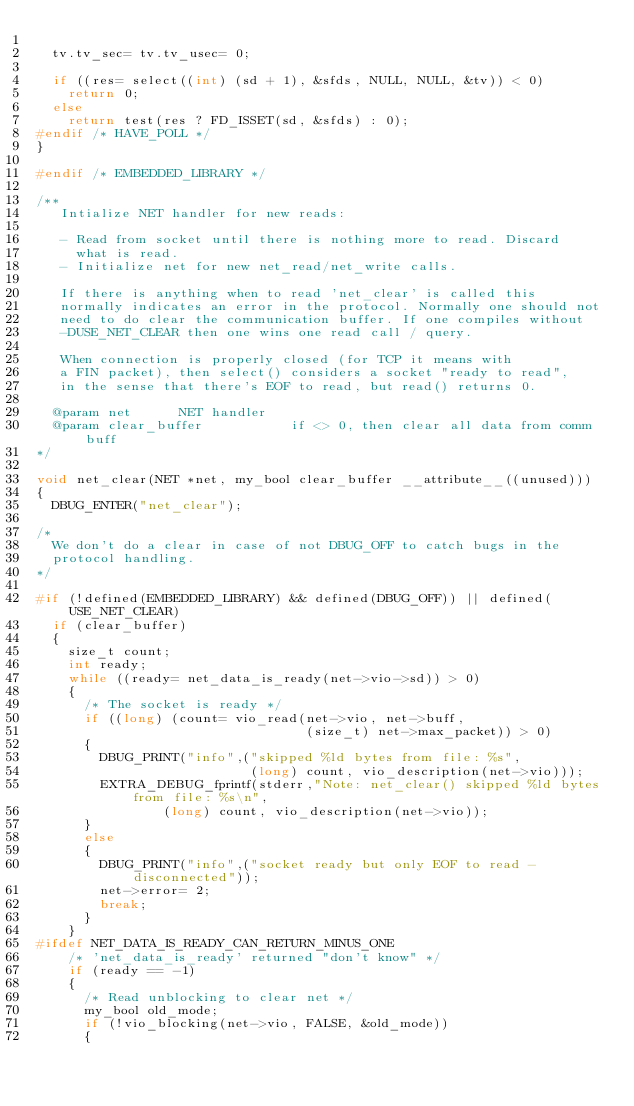<code> <loc_0><loc_0><loc_500><loc_500><_C++_>
  tv.tv_sec= tv.tv_usec= 0;

  if ((res= select((int) (sd + 1), &sfds, NULL, NULL, &tv)) < 0)
    return 0;
  else
    return test(res ? FD_ISSET(sd, &sfds) : 0);
#endif /* HAVE_POLL */
}

#endif /* EMBEDDED_LIBRARY */

/**
   Intialize NET handler for new reads:

   - Read from socket until there is nothing more to read. Discard
     what is read.
   - Initialize net for new net_read/net_write calls.

   If there is anything when to read 'net_clear' is called this
   normally indicates an error in the protocol. Normally one should not
   need to do clear the communication buffer. If one compiles without
   -DUSE_NET_CLEAR then one wins one read call / query.

   When connection is properly closed (for TCP it means with
   a FIN packet), then select() considers a socket "ready to read",
   in the sense that there's EOF to read, but read() returns 0.

  @param net			NET handler
  @param clear_buffer           if <> 0, then clear all data from comm buff
*/

void net_clear(NET *net, my_bool clear_buffer __attribute__((unused)))
{
  DBUG_ENTER("net_clear");

/*
  We don't do a clear in case of not DBUG_OFF to catch bugs in the
  protocol handling.
*/

#if (!defined(EMBEDDED_LIBRARY) && defined(DBUG_OFF)) || defined(USE_NET_CLEAR)
  if (clear_buffer)
  {
    size_t count;
    int ready;
    while ((ready= net_data_is_ready(net->vio->sd)) > 0)
    {
      /* The socket is ready */
      if ((long) (count= vio_read(net->vio, net->buff,
                                  (size_t) net->max_packet)) > 0)
      {
        DBUG_PRINT("info",("skipped %ld bytes from file: %s",
                           (long) count, vio_description(net->vio)));
        EXTRA_DEBUG_fprintf(stderr,"Note: net_clear() skipped %ld bytes from file: %s\n",
                (long) count, vio_description(net->vio));
      }
      else
      {
        DBUG_PRINT("info",("socket ready but only EOF to read - disconnected"));
        net->error= 2;
        break;
      }
    }
#ifdef NET_DATA_IS_READY_CAN_RETURN_MINUS_ONE
    /* 'net_data_is_ready' returned "don't know" */
    if (ready == -1)
    {
      /* Read unblocking to clear net */
      my_bool old_mode;
      if (!vio_blocking(net->vio, FALSE, &old_mode))
      {</code> 